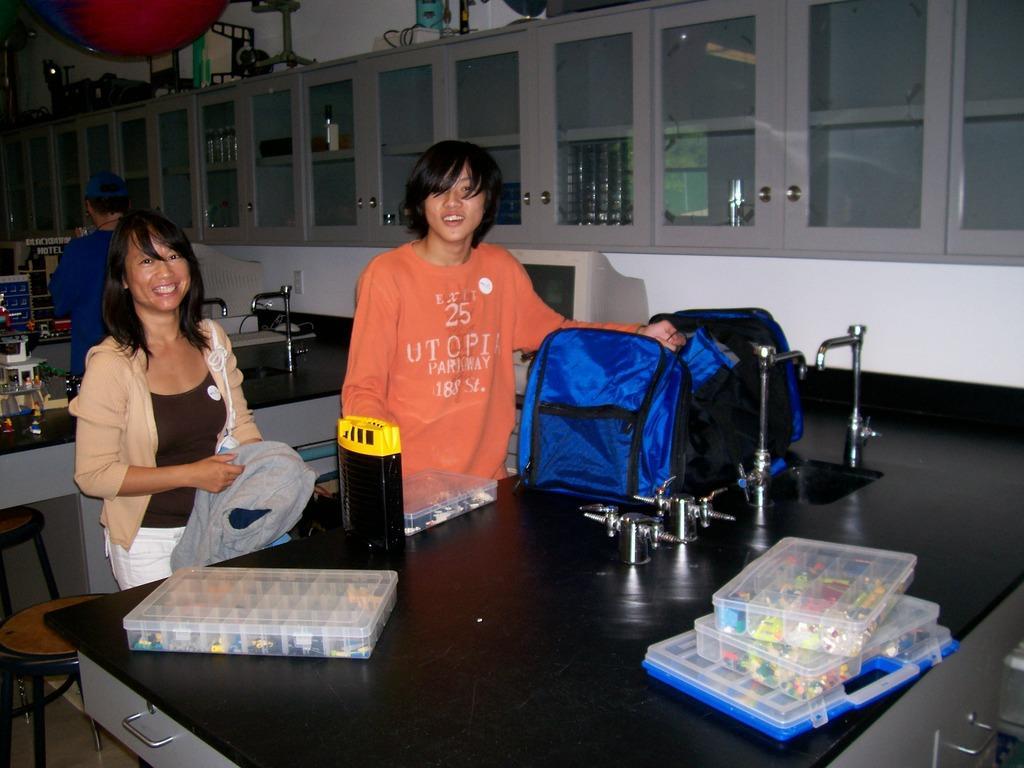Describe this image in one or two sentences. The picture is taken inside a room. There are tables and chairs. In the back we can see cupboard. On the table there are few boxes, bag,tap. Behind the table there are two persons. They are standing. They are smiling. In the background there are other table and a person is standing. 